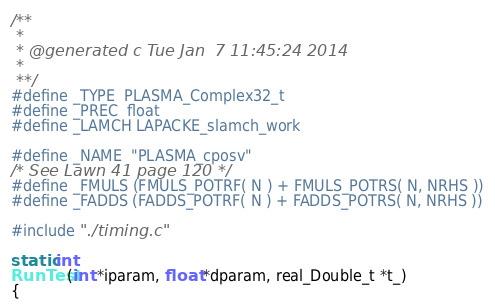Convert code to text. <code><loc_0><loc_0><loc_500><loc_500><_C_>/**
 *
 * @generated c Tue Jan  7 11:45:24 2014
 *
 **/
#define _TYPE  PLASMA_Complex32_t
#define _PREC  float
#define _LAMCH LAPACKE_slamch_work

#define _NAME  "PLASMA_cposv"
/* See Lawn 41 page 120 */
#define _FMULS (FMULS_POTRF( N ) + FMULS_POTRS( N, NRHS ))
#define _FADDS (FADDS_POTRF( N ) + FADDS_POTRS( N, NRHS ))

#include "./timing.c"

static int
RunTest(int *iparam, float *dparam, real_Double_t *t_) 
{</code> 